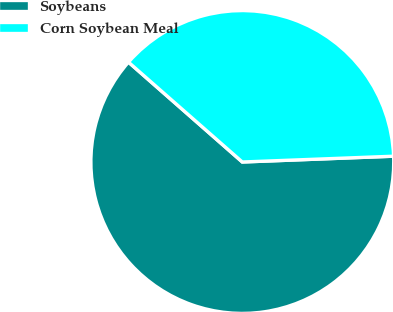Convert chart to OTSL. <chart><loc_0><loc_0><loc_500><loc_500><pie_chart><fcel>Soybeans<fcel>Corn Soybean Meal<nl><fcel>62.07%<fcel>37.93%<nl></chart> 